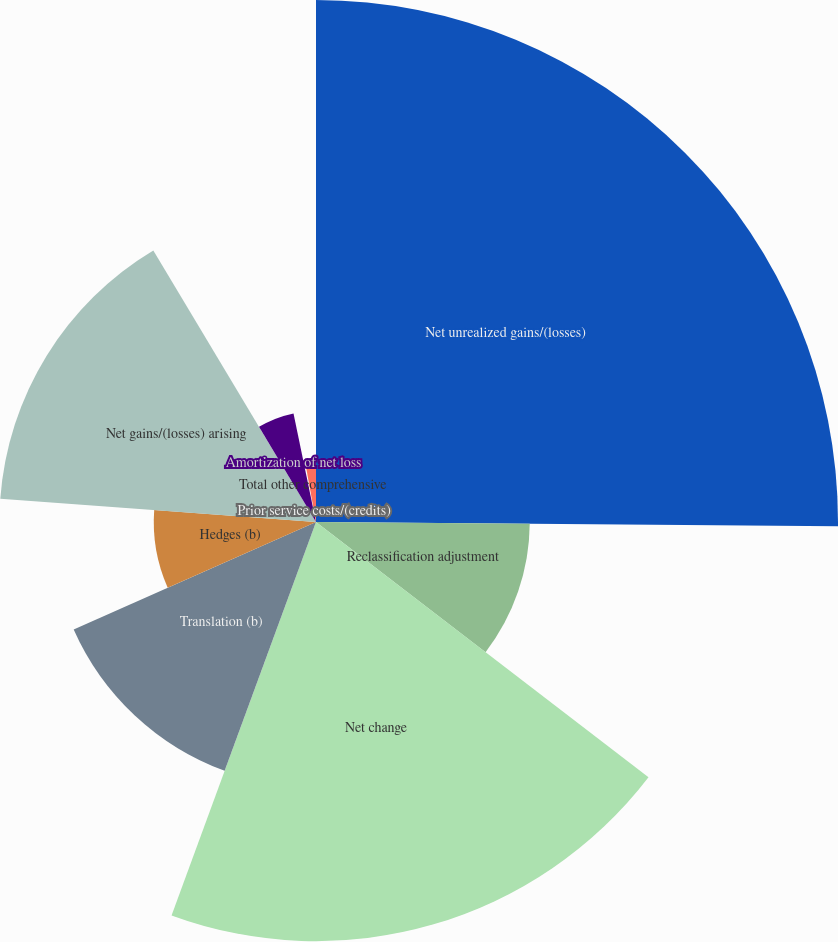Convert chart. <chart><loc_0><loc_0><loc_500><loc_500><pie_chart><fcel>Net unrealized gains/(losses)<fcel>Reclassification adjustment<fcel>Net change<fcel>Translation (b)<fcel>Hedges (b)<fcel>Net gains/(losses) arising<fcel>Amortization of net loss<fcel>Prior service costs/(credits)<fcel>Total other comprehensive<nl><fcel>25.13%<fcel>10.29%<fcel>20.18%<fcel>12.76%<fcel>7.81%<fcel>15.24%<fcel>5.34%<fcel>0.39%<fcel>2.86%<nl></chart> 